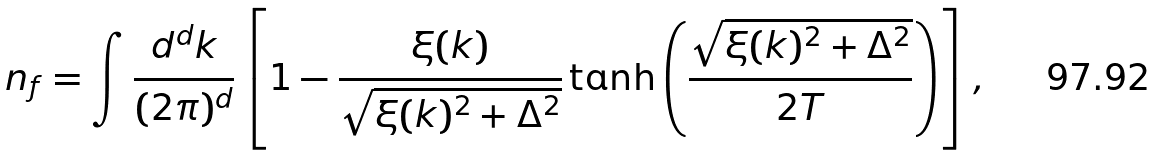<formula> <loc_0><loc_0><loc_500><loc_500>n _ { f } = \int \frac { d ^ { d } k } { ( 2 \pi ) ^ { d } } \left [ 1 - \frac { \xi ( { k } ) } { \sqrt { \xi ( { k } ) ^ { 2 } + \Delta ^ { 2 } } } \tanh \left ( \frac { \sqrt { \xi ( { k } ) ^ { 2 } + \Delta ^ { 2 } } } { 2 T } \right ) \right ] ,</formula> 